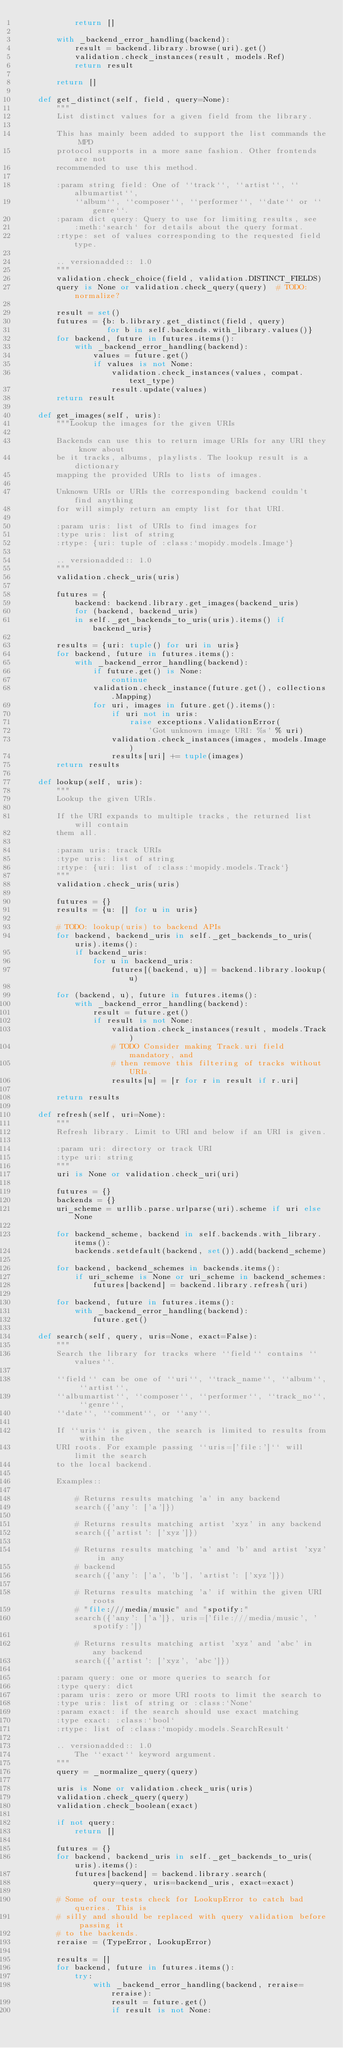<code> <loc_0><loc_0><loc_500><loc_500><_Python_>            return []

        with _backend_error_handling(backend):
            result = backend.library.browse(uri).get()
            validation.check_instances(result, models.Ref)
            return result

        return []

    def get_distinct(self, field, query=None):
        """
        List distinct values for a given field from the library.

        This has mainly been added to support the list commands the MPD
        protocol supports in a more sane fashion. Other frontends are not
        recommended to use this method.

        :param string field: One of ``track``, ``artist``, ``albumartist``,
            ``album``, ``composer``, ``performer``, ``date`` or ``genre``.
        :param dict query: Query to use for limiting results, see
            :meth:`search` for details about the query format.
        :rtype: set of values corresponding to the requested field type.

        .. versionadded:: 1.0
        """
        validation.check_choice(field, validation.DISTINCT_FIELDS)
        query is None or validation.check_query(query)  # TODO: normalize?

        result = set()
        futures = {b: b.library.get_distinct(field, query)
                   for b in self.backends.with_library.values()}
        for backend, future in futures.items():
            with _backend_error_handling(backend):
                values = future.get()
                if values is not None:
                    validation.check_instances(values, compat.text_type)
                    result.update(values)
        return result

    def get_images(self, uris):
        """Lookup the images for the given URIs

        Backends can use this to return image URIs for any URI they know about
        be it tracks, albums, playlists. The lookup result is a dictionary
        mapping the provided URIs to lists of images.

        Unknown URIs or URIs the corresponding backend couldn't find anything
        for will simply return an empty list for that URI.

        :param uris: list of URIs to find images for
        :type uris: list of string
        :rtype: {uri: tuple of :class:`mopidy.models.Image`}

        .. versionadded:: 1.0
        """
        validation.check_uris(uris)

        futures = {
            backend: backend.library.get_images(backend_uris)
            for (backend, backend_uris)
            in self._get_backends_to_uris(uris).items() if backend_uris}

        results = {uri: tuple() for uri in uris}
        for backend, future in futures.items():
            with _backend_error_handling(backend):
                if future.get() is None:
                    continue
                validation.check_instance(future.get(), collections.Mapping)
                for uri, images in future.get().items():
                    if uri not in uris:
                        raise exceptions.ValidationError(
                            'Got unknown image URI: %s' % uri)
                    validation.check_instances(images, models.Image)
                    results[uri] += tuple(images)
        return results

    def lookup(self, uris):
        """
        Lookup the given URIs.

        If the URI expands to multiple tracks, the returned list will contain
        them all.

        :param uris: track URIs
        :type uris: list of string
        :rtype: {uri: list of :class:`mopidy.models.Track`}
        """
        validation.check_uris(uris)

        futures = {}
        results = {u: [] for u in uris}

        # TODO: lookup(uris) to backend APIs
        for backend, backend_uris in self._get_backends_to_uris(uris).items():
            if backend_uris:
                for u in backend_uris:
                    futures[(backend, u)] = backend.library.lookup(u)

        for (backend, u), future in futures.items():
            with _backend_error_handling(backend):
                result = future.get()
                if result is not None:
                    validation.check_instances(result, models.Track)
                    # TODO Consider making Track.uri field mandatory, and
                    # then remove this filtering of tracks without URIs.
                    results[u] = [r for r in result if r.uri]

        return results

    def refresh(self, uri=None):
        """
        Refresh library. Limit to URI and below if an URI is given.

        :param uri: directory or track URI
        :type uri: string
        """
        uri is None or validation.check_uri(uri)

        futures = {}
        backends = {}
        uri_scheme = urllib.parse.urlparse(uri).scheme if uri else None

        for backend_scheme, backend in self.backends.with_library.items():
            backends.setdefault(backend, set()).add(backend_scheme)

        for backend, backend_schemes in backends.items():
            if uri_scheme is None or uri_scheme in backend_schemes:
                futures[backend] = backend.library.refresh(uri)

        for backend, future in futures.items():
            with _backend_error_handling(backend):
                future.get()

    def search(self, query, uris=None, exact=False):
        """
        Search the library for tracks where ``field`` contains ``values``.

        ``field`` can be one of ``uri``, ``track_name``, ``album``, ``artist``,
        ``albumartist``, ``composer``, ``performer``, ``track_no``, ``genre``,
        ``date``, ``comment``, or ``any``.

        If ``uris`` is given, the search is limited to results from within the
        URI roots. For example passing ``uris=['file:']`` will limit the search
        to the local backend.

        Examples::

            # Returns results matching 'a' in any backend
            search({'any': ['a']})

            # Returns results matching artist 'xyz' in any backend
            search({'artist': ['xyz']})

            # Returns results matching 'a' and 'b' and artist 'xyz' in any
            # backend
            search({'any': ['a', 'b'], 'artist': ['xyz']})

            # Returns results matching 'a' if within the given URI roots
            # "file:///media/music" and "spotify:"
            search({'any': ['a']}, uris=['file:///media/music', 'spotify:'])

            # Returns results matching artist 'xyz' and 'abc' in any backend
            search({'artist': ['xyz', 'abc']})

        :param query: one or more queries to search for
        :type query: dict
        :param uris: zero or more URI roots to limit the search to
        :type uris: list of string or :class:`None`
        :param exact: if the search should use exact matching
        :type exact: :class:`bool`
        :rtype: list of :class:`mopidy.models.SearchResult`

        .. versionadded:: 1.0
            The ``exact`` keyword argument.
        """
        query = _normalize_query(query)

        uris is None or validation.check_uris(uris)
        validation.check_query(query)
        validation.check_boolean(exact)

        if not query:
            return []

        futures = {}
        for backend, backend_uris in self._get_backends_to_uris(uris).items():
            futures[backend] = backend.library.search(
                query=query, uris=backend_uris, exact=exact)

        # Some of our tests check for LookupError to catch bad queries. This is
        # silly and should be replaced with query validation before passing it
        # to the backends.
        reraise = (TypeError, LookupError)

        results = []
        for backend, future in futures.items():
            try:
                with _backend_error_handling(backend, reraise=reraise):
                    result = future.get()
                    if result is not None:</code> 